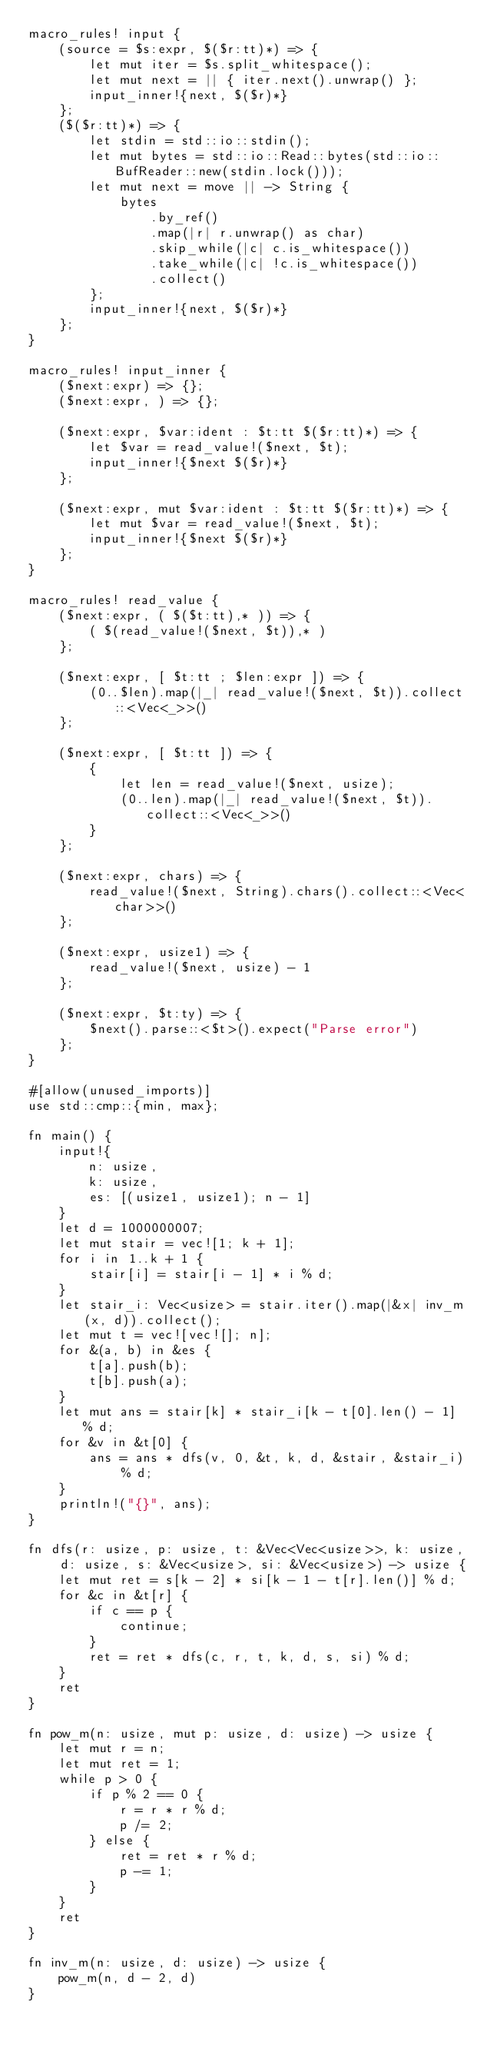<code> <loc_0><loc_0><loc_500><loc_500><_Rust_>macro_rules! input {
    (source = $s:expr, $($r:tt)*) => {
        let mut iter = $s.split_whitespace();
        let mut next = || { iter.next().unwrap() };
        input_inner!{next, $($r)*}
    };
    ($($r:tt)*) => {
        let stdin = std::io::stdin();
        let mut bytes = std::io::Read::bytes(std::io::BufReader::new(stdin.lock()));
        let mut next = move || -> String {
            bytes
                .by_ref()
                .map(|r| r.unwrap() as char)
                .skip_while(|c| c.is_whitespace())
                .take_while(|c| !c.is_whitespace())
                .collect()
        };
        input_inner!{next, $($r)*}
    };
}

macro_rules! input_inner {
    ($next:expr) => {};
    ($next:expr, ) => {};

    ($next:expr, $var:ident : $t:tt $($r:tt)*) => {
        let $var = read_value!($next, $t);
        input_inner!{$next $($r)*}
    };

    ($next:expr, mut $var:ident : $t:tt $($r:tt)*) => {
        let mut $var = read_value!($next, $t);
        input_inner!{$next $($r)*}
    };
}

macro_rules! read_value {
    ($next:expr, ( $($t:tt),* )) => {
        ( $(read_value!($next, $t)),* )
    };

    ($next:expr, [ $t:tt ; $len:expr ]) => {
        (0..$len).map(|_| read_value!($next, $t)).collect::<Vec<_>>()
    };

    ($next:expr, [ $t:tt ]) => {
        {
            let len = read_value!($next, usize);
            (0..len).map(|_| read_value!($next, $t)).collect::<Vec<_>>()
        }
    };

    ($next:expr, chars) => {
        read_value!($next, String).chars().collect::<Vec<char>>()
    };

    ($next:expr, usize1) => {
        read_value!($next, usize) - 1
    };

    ($next:expr, $t:ty) => {
        $next().parse::<$t>().expect("Parse error")
    };
}

#[allow(unused_imports)]
use std::cmp::{min, max};

fn main() {
    input!{
        n: usize,
        k: usize,
        es: [(usize1, usize1); n - 1]
    }
    let d = 1000000007;
    let mut stair = vec![1; k + 1];
    for i in 1..k + 1 {
        stair[i] = stair[i - 1] * i % d;
    }
    let stair_i: Vec<usize> = stair.iter().map(|&x| inv_m(x, d)).collect();
    let mut t = vec![vec![]; n];
    for &(a, b) in &es {
        t[a].push(b);
        t[b].push(a);
    }
    let mut ans = stair[k] * stair_i[k - t[0].len() - 1] % d;
    for &v in &t[0] {
        ans = ans * dfs(v, 0, &t, k, d, &stair, &stair_i) % d;
    }
    println!("{}", ans);
}

fn dfs(r: usize, p: usize, t: &Vec<Vec<usize>>, k: usize, d: usize, s: &Vec<usize>, si: &Vec<usize>) -> usize {
    let mut ret = s[k - 2] * si[k - 1 - t[r].len()] % d;
    for &c in &t[r] {
        if c == p {
            continue;
        }
        ret = ret * dfs(c, r, t, k, d, s, si) % d;
    }
    ret
}

fn pow_m(n: usize, mut p: usize, d: usize) -> usize {
    let mut r = n;
    let mut ret = 1;
    while p > 0 {
        if p % 2 == 0 {
            r = r * r % d;
            p /= 2;
        } else {
            ret = ret * r % d;
            p -= 1;
        }
    }
    ret
}

fn inv_m(n: usize, d: usize) -> usize {
    pow_m(n, d - 2, d)
}
</code> 